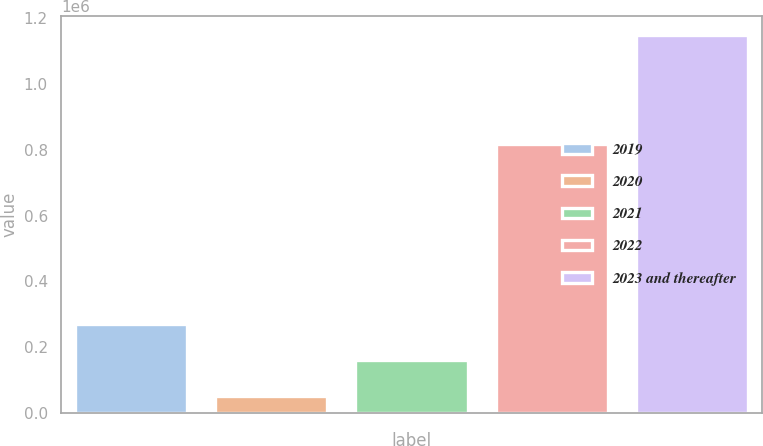Convert chart. <chart><loc_0><loc_0><loc_500><loc_500><bar_chart><fcel>2019<fcel>2020<fcel>2021<fcel>2022<fcel>2023 and thereafter<nl><fcel>271250<fcel>51562<fcel>161406<fcel>818000<fcel>1.15e+06<nl></chart> 